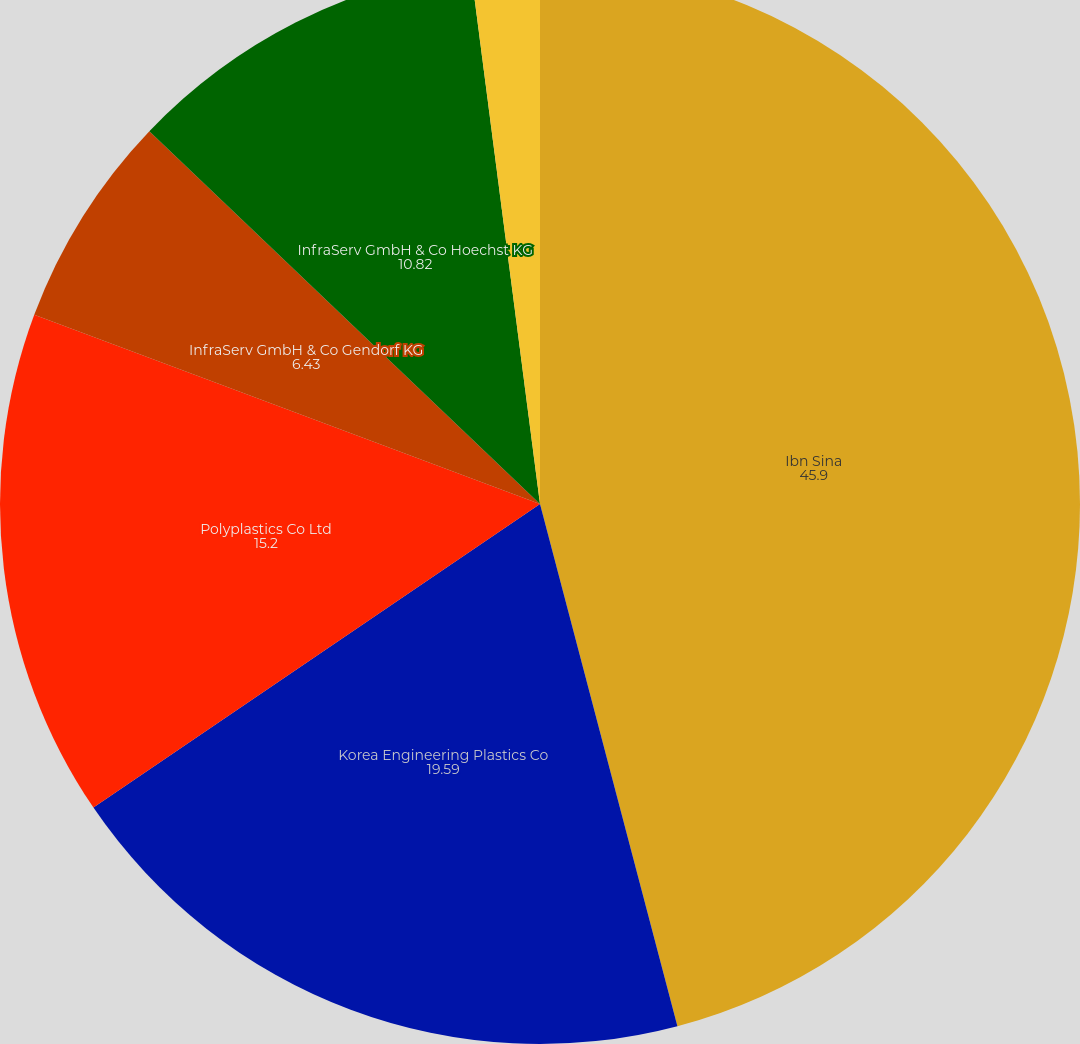<chart> <loc_0><loc_0><loc_500><loc_500><pie_chart><fcel>Ibn Sina<fcel>Korea Engineering Plastics Co<fcel>Polyplastics Co Ltd<fcel>InfraServ GmbH & Co Gendorf KG<fcel>InfraServ GmbH & Co Hoechst KG<fcel>InfraServ GmbH & Co Knapsack<nl><fcel>45.9%<fcel>19.59%<fcel>15.2%<fcel>6.43%<fcel>10.82%<fcel>2.05%<nl></chart> 